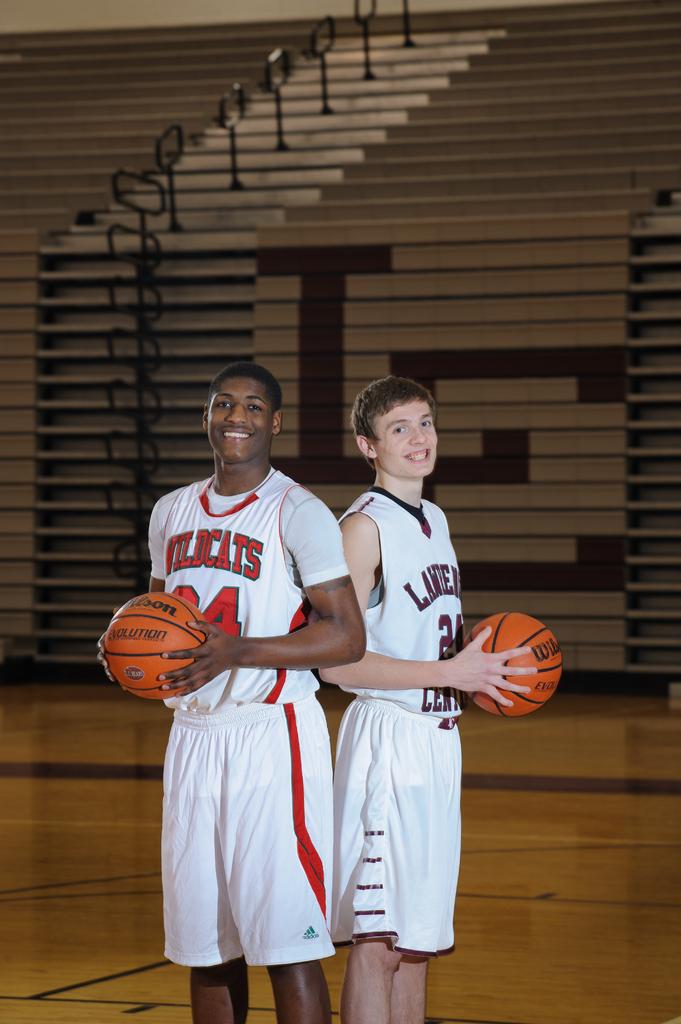What number is the kid in red?
Your response must be concise. Unanswerable. 